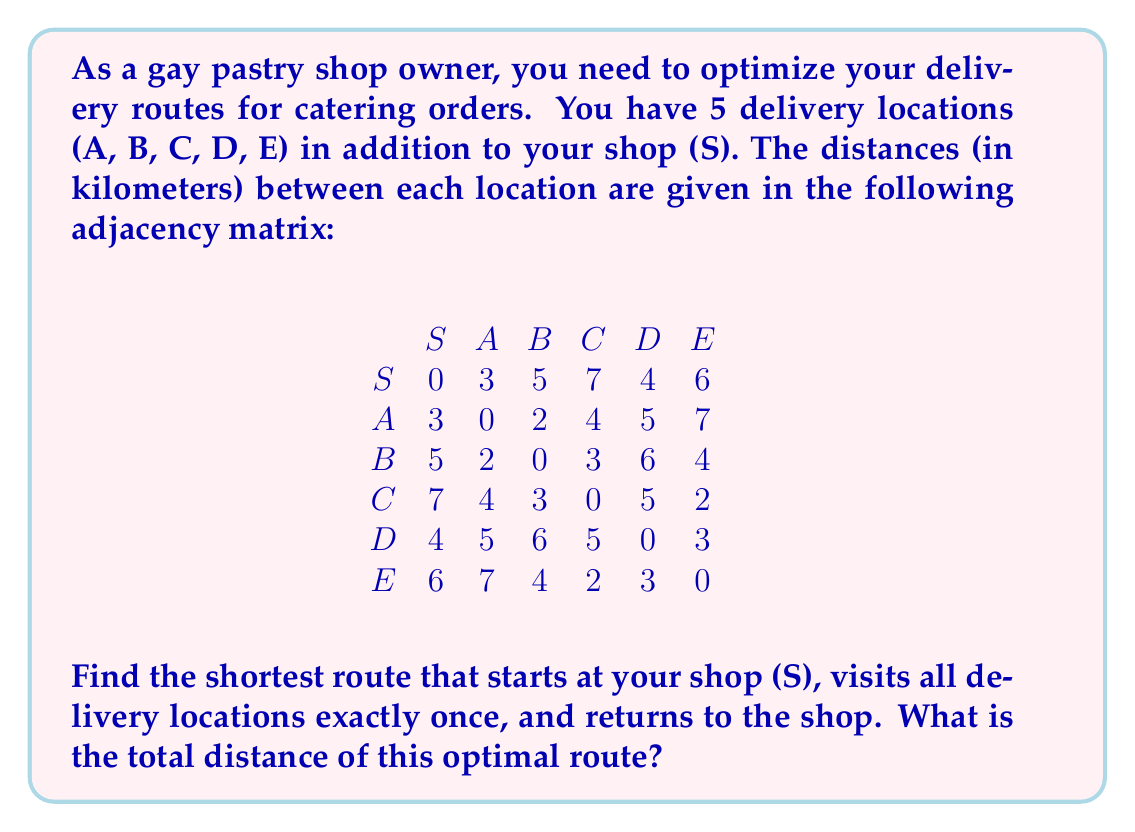Give your solution to this math problem. To solve this problem, we need to find the Hamiltonian cycle with the minimum total weight in the given graph. This is known as the Traveling Salesman Problem (TSP).

For a small graph like this, we can use the brute-force method to find the optimal solution:

1. List all possible permutations of the delivery locations (A, B, C, D, E).
2. For each permutation, calculate the total distance of the route including the start and end at the shop (S).
3. Choose the permutation with the minimum total distance.

Let's go through the process:

1. There are 5! = 120 possible permutations of (A, B, C, D, E).

2. For each permutation, we calculate the distance:
   S → [Permutation] → S

3. After calculating all 120 routes, we find that the minimum distance is achieved by the following route:
   S → A → B → C → E → D → S

4. Let's calculate the total distance of this optimal route:
   $d = d_{SA} + d_{AB} + d_{BC} + d_{CE} + d_{ED} + d_{DS}$
   $d = 3 + 2 + 3 + 2 + 3 + 4 = 17$ km

Therefore, the optimal route has a total distance of 17 km.

Note: In practice, for larger graphs, more efficient algorithms like the Held-Karp algorithm or heuristic methods like the Lin-Kernighan heuristic would be used to solve the TSP, as the brute-force method becomes impractical due to its exponential time complexity.
Answer: The shortest route is S → A → B → C → E → D → S, with a total distance of 17 km. 